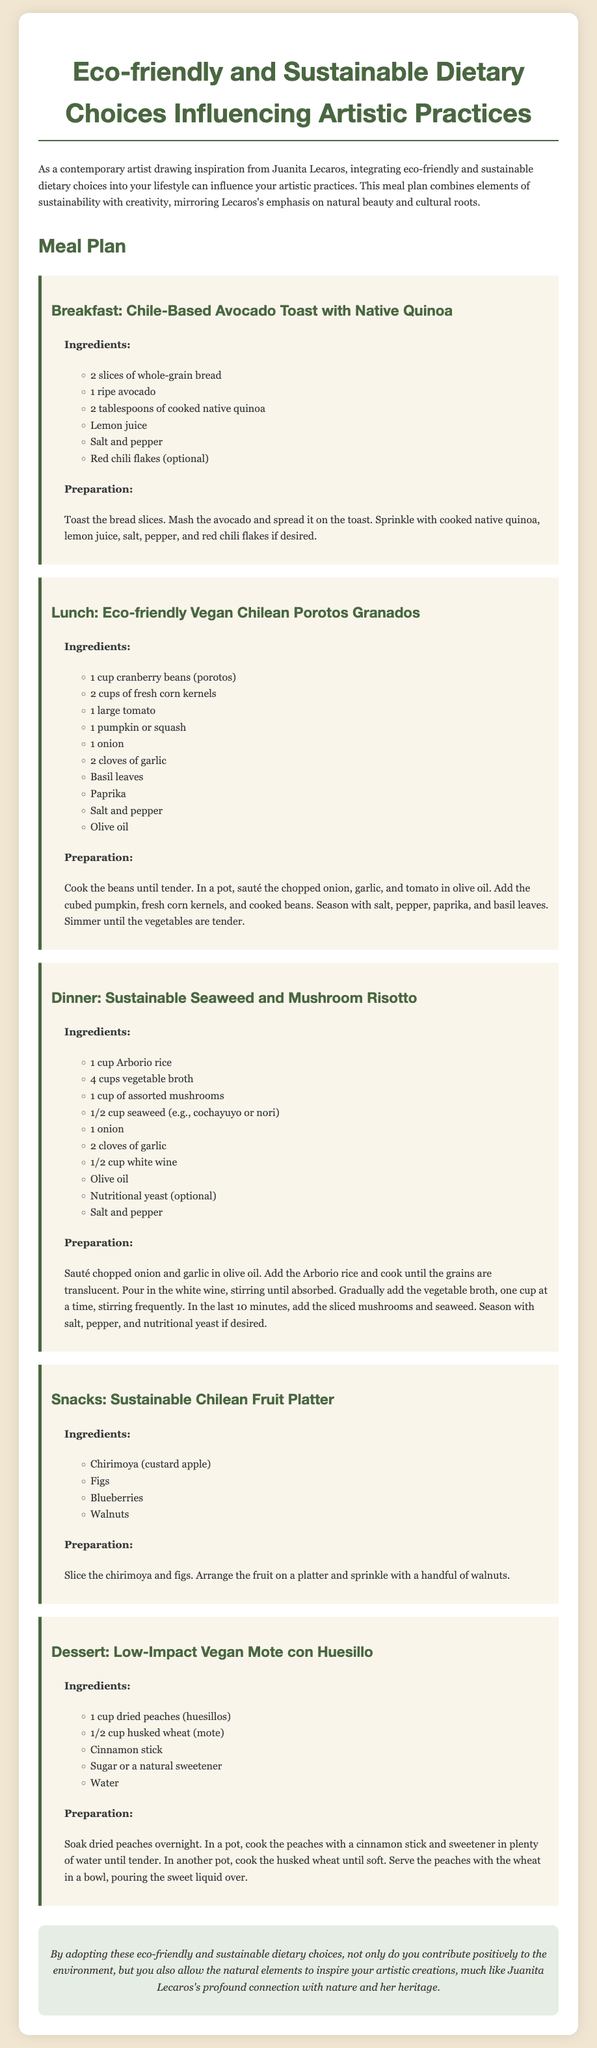What is the title of the meal plan? The title of the meal plan is stated at the top of the document.
Answer: Eco-friendly and Sustainable Dietary Choices Influencing Artistic Practices How many servings of cranberry beans are listed in the lunch recipe? The number of servings is found in the lunch recipe section.
Answer: 1 cup Which fruit is included in the snack recipe? The snack recipe lists the fruits that are used for this particular snack.
Answer: Chirimoya What type of rice is used in the dinner recipe? The dinner recipe specifies the type of rice to be used for the dish.
Answer: Arborio What is the primary vegetable used in the breakfast recipe? The main ingredient in the breakfast recipe is identified in the ingredient list.
Answer: Avocado How long should dried peaches be soaked? The soaking time for the dried peaches is detailed in the dessert section.
Answer: Overnight What type of bread is used for breakfast? The bread specified in the breakfast recipe is mentioned in the ingredients list.
Answer: Whole-grain bread Which meal incorporates mushrooms? The meal that includes mushrooms is described in the dinner preparation section.
Answer: Dinner What emphasizes the connection between diet and art in the document conclusion? The document mentions the influence of eco-friendly choices on artistic practices in the conclusion.
Answer: Natural elements and heritage 